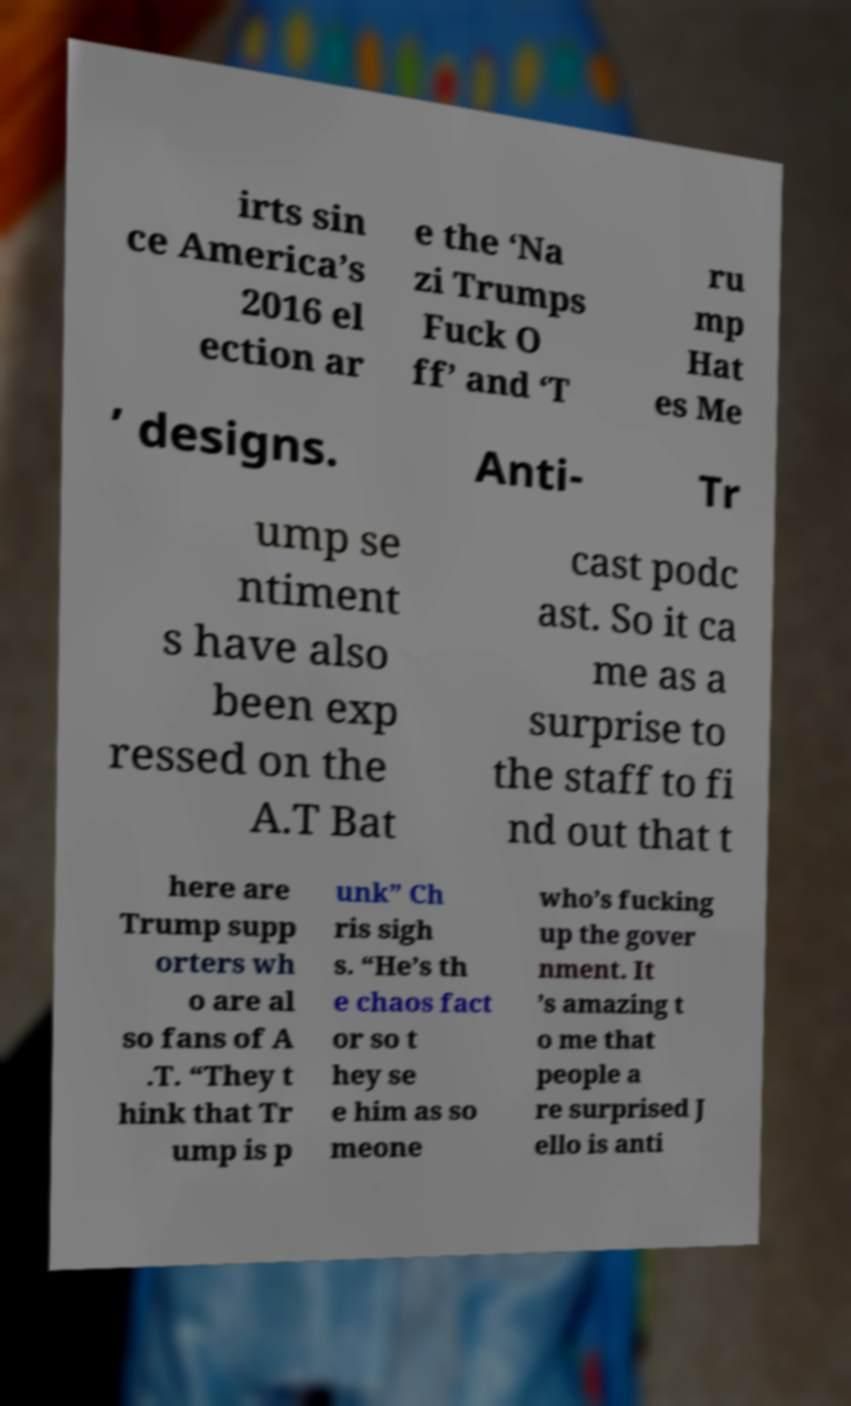Can you accurately transcribe the text from the provided image for me? irts sin ce America’s 2016 el ection ar e the ‘Na zi Trumps Fuck O ff’ and ‘T ru mp Hat es Me ’ designs. Anti- Tr ump se ntiment s have also been exp ressed on the A.T Bat cast podc ast. So it ca me as a surprise to the staff to fi nd out that t here are Trump supp orters wh o are al so fans of A .T. “They t hink that Tr ump is p unk” Ch ris sigh s. “He’s th e chaos fact or so t hey se e him as so meone who’s fucking up the gover nment. It ’s amazing t o me that people a re surprised J ello is anti 